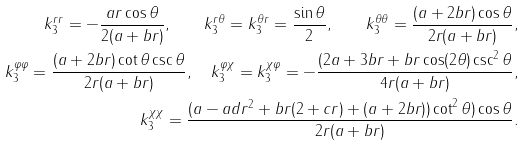Convert formula to latex. <formula><loc_0><loc_0><loc_500><loc_500>k ^ { r r } _ { 3 } = - \frac { a r \cos \theta } { 2 ( a + b r ) } , \quad k ^ { r \theta } _ { 3 } = k ^ { \theta r } _ { 3 } = \frac { \sin \theta } { 2 } , \quad k ^ { \theta \theta } _ { 3 } = \frac { ( a + 2 b r ) \cos \theta } { 2 r ( a + b r ) } , \\ k ^ { \varphi \varphi } _ { 3 } = \frac { ( a + 2 b r ) \cot \theta \csc \theta } { 2 r ( a + b r ) } , \quad k ^ { \varphi \chi } _ { 3 } = k ^ { \chi \varphi } _ { 3 } = - \frac { ( 2 a + 3 b r + b r \cos ( 2 \theta ) \csc ^ { 2 } \theta } { 4 r ( a + b r ) } , \\ k ^ { \chi \chi } _ { 3 } = \frac { ( a - a d r ^ { 2 } + b r ( 2 + c r ) + ( a + 2 b r ) ) \cot ^ { 2 } \theta ) \cos \theta } { 2 r ( a + b r ) } .</formula> 